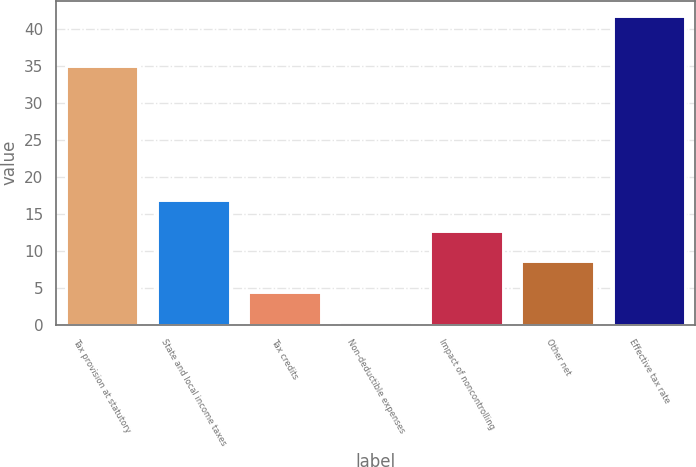<chart> <loc_0><loc_0><loc_500><loc_500><bar_chart><fcel>Tax provision at statutory<fcel>State and local income taxes<fcel>Tax credits<fcel>Non-deductible expenses<fcel>Impact of noncontrolling<fcel>Other net<fcel>Effective tax rate<nl><fcel>35<fcel>16.9<fcel>4.45<fcel>0.3<fcel>12.75<fcel>8.6<fcel>41.8<nl></chart> 